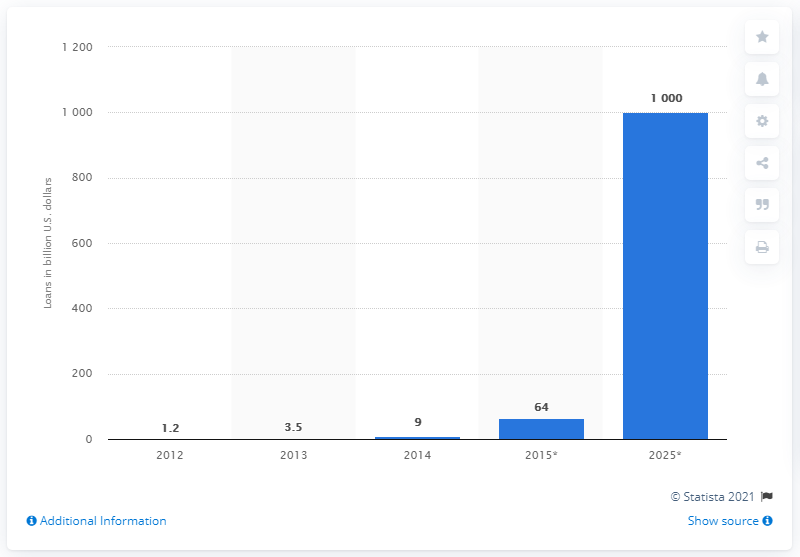Mention a couple of crucial points in this snapshot. The global peer-to-peer (P2P) lending market was valued at approximately 3.5 billion dollars in 2013. 